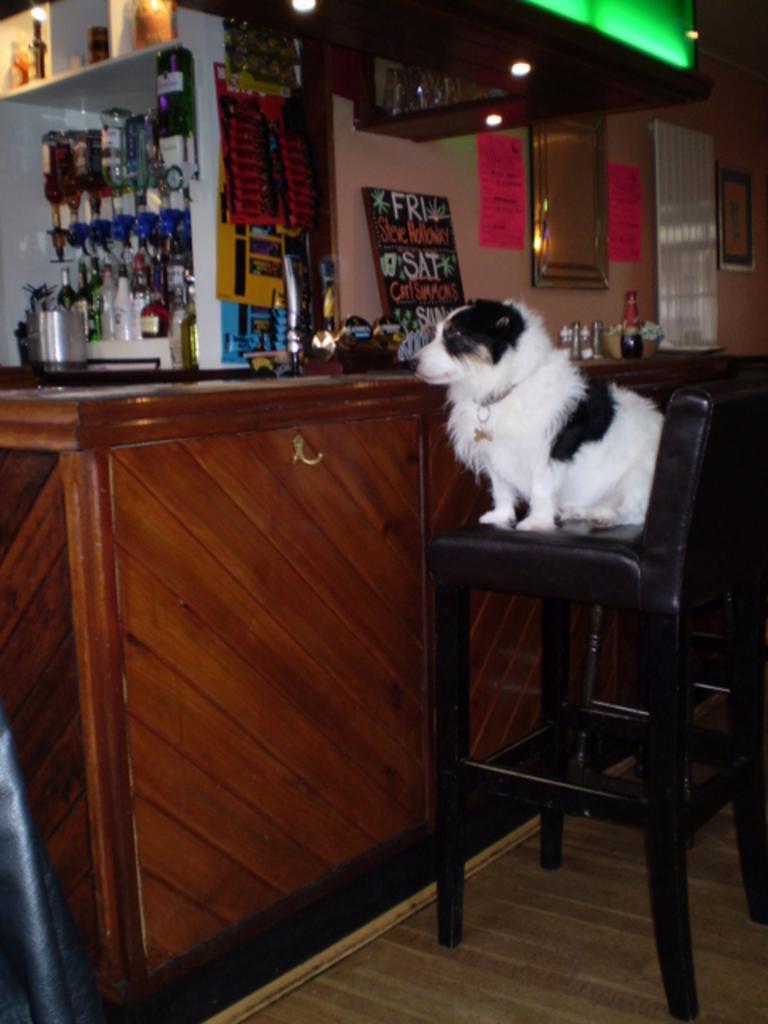Can you describe this image briefly? In this image we can see one dog sitting on the chair, one wooden object looks like cupboard on the floor, some bottles in the shelf's, one object attached to the wooden cupboard on the floor, some objects in the shelf's, one board with text, one black object at the bottom left side corner of the image, some objects in the wooden cupboard at the top of the image, some objects on the wooden cupboard on the floor and some objects attached to the wall. 